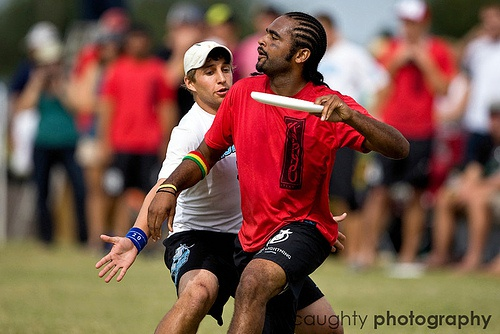Describe the objects in this image and their specific colors. I can see people in gray, black, red, maroon, and brown tones, people in gray, black, and white tones, people in gray, black, brown, and maroon tones, people in gray, red, black, maroon, and brown tones, and people in gray, black, teal, and maroon tones in this image. 